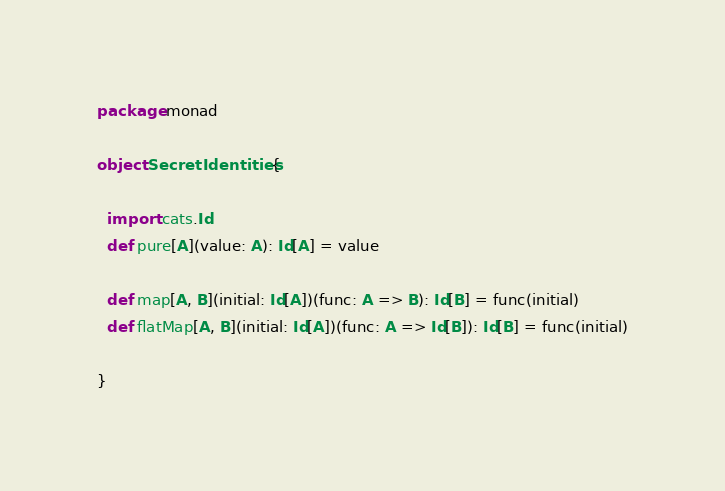<code> <loc_0><loc_0><loc_500><loc_500><_Scala_>package monad

object SecretIdentities {

  import cats.Id
  def pure[A](value: A): Id[A] = value

  def map[A, B](initial: Id[A])(func: A => B): Id[B] = func(initial)
  def flatMap[A, B](initial: Id[A])(func: A => Id[B]): Id[B] = func(initial)

}
</code> 